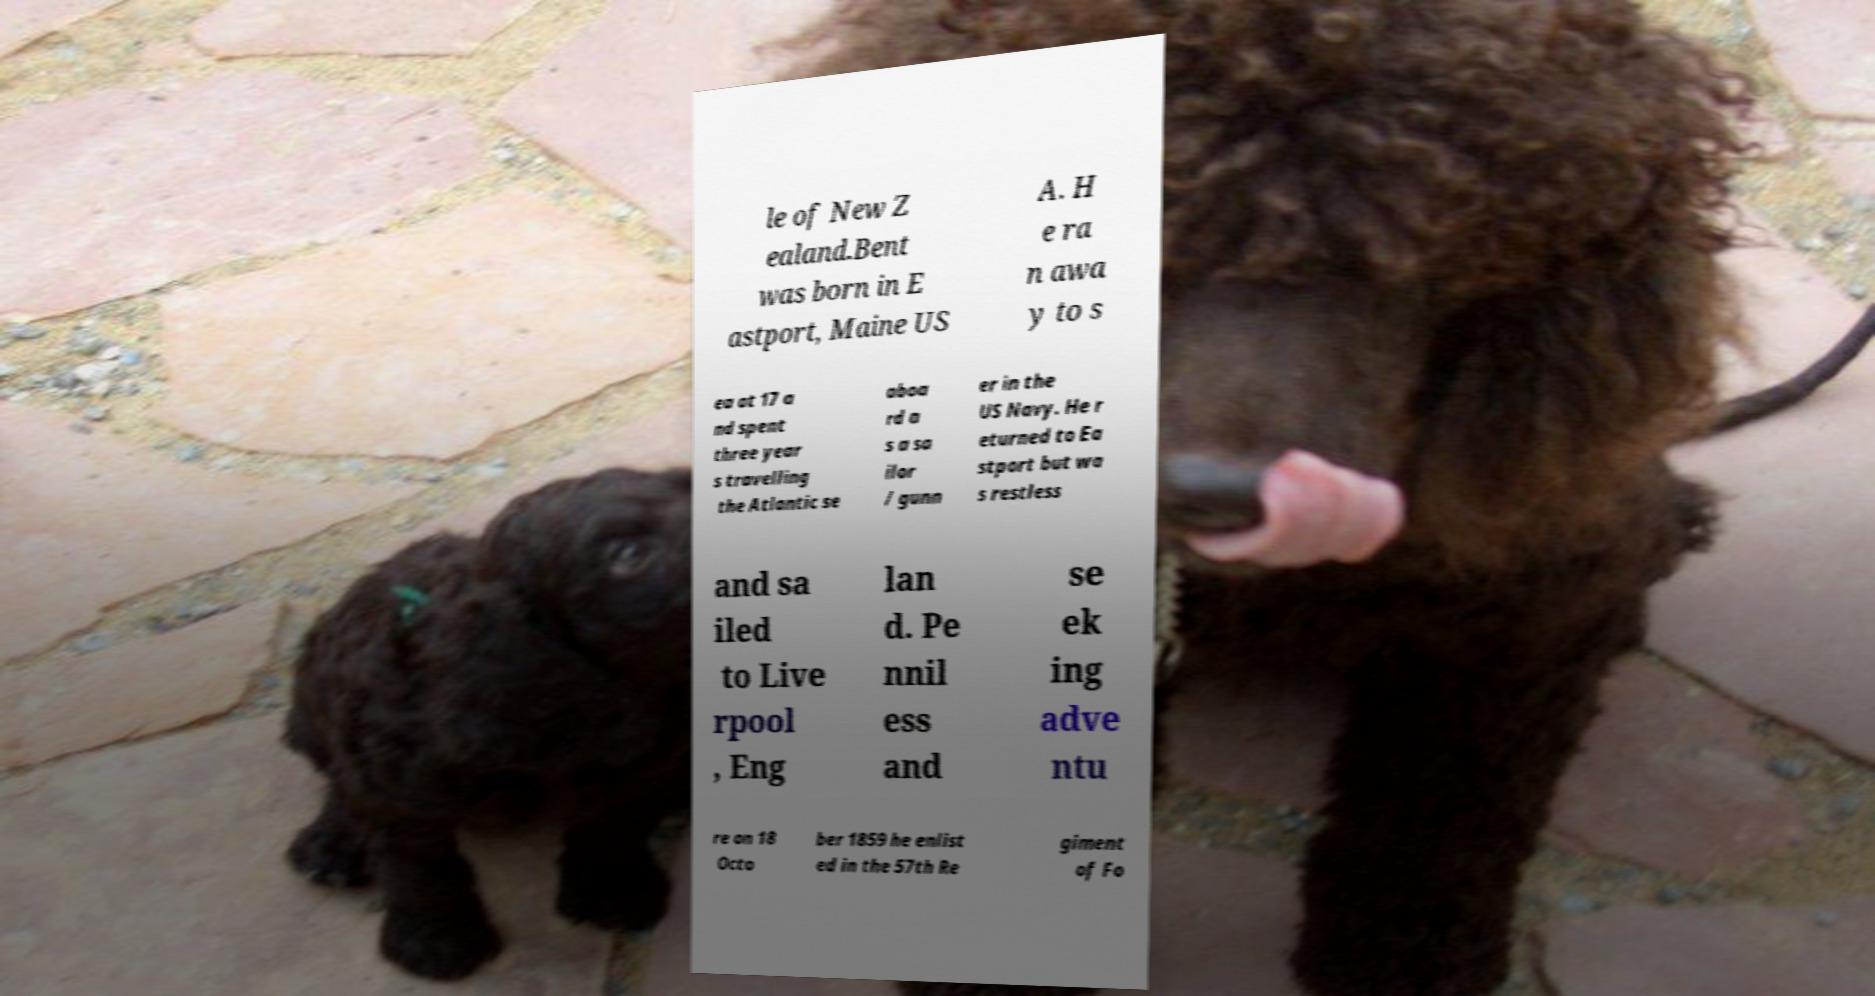What messages or text are displayed in this image? I need them in a readable, typed format. le of New Z ealand.Bent was born in E astport, Maine US A. H e ra n awa y to s ea at 17 a nd spent three year s travelling the Atlantic se aboa rd a s a sa ilor / gunn er in the US Navy. He r eturned to Ea stport but wa s restless and sa iled to Live rpool , Eng lan d. Pe nnil ess and se ek ing adve ntu re on 18 Octo ber 1859 he enlist ed in the 57th Re giment of Fo 